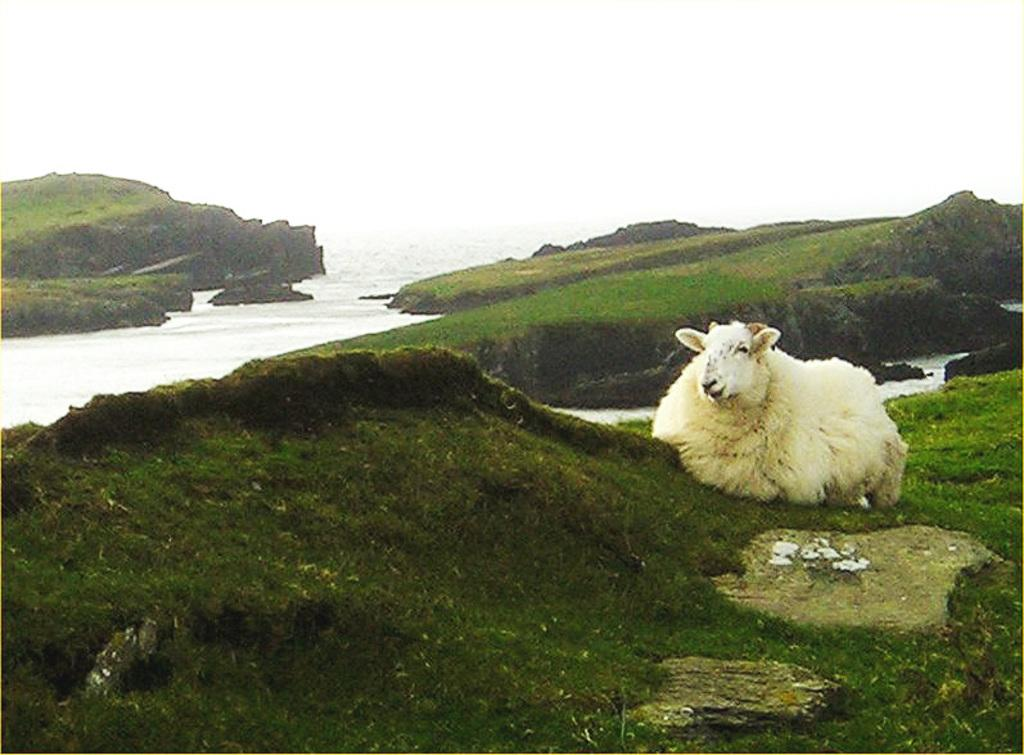What animal can be seen on the grass in the image? There is a sheep on the grass on the right side of the image. What type of environment is visible in the background of the image? There is water visible in the background of the image. What type of flesh can be seen hanging from the tree in the image? There is no flesh or tree present in the image; it features a sheep on the grass with water visible in the background. 